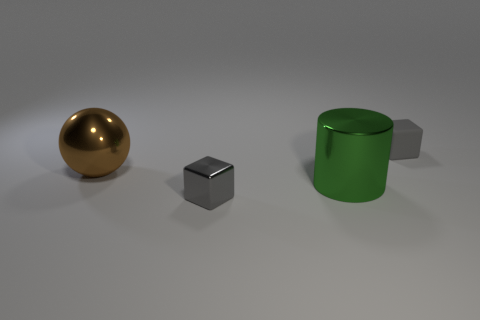Add 1 tiny matte things. How many objects exist? 5 Subtract all cylinders. How many objects are left? 3 Add 1 gray blocks. How many gray blocks exist? 3 Subtract 1 brown balls. How many objects are left? 3 Subtract all metallic blocks. Subtract all tiny rubber spheres. How many objects are left? 3 Add 1 big green metallic cylinders. How many big green metallic cylinders are left? 2 